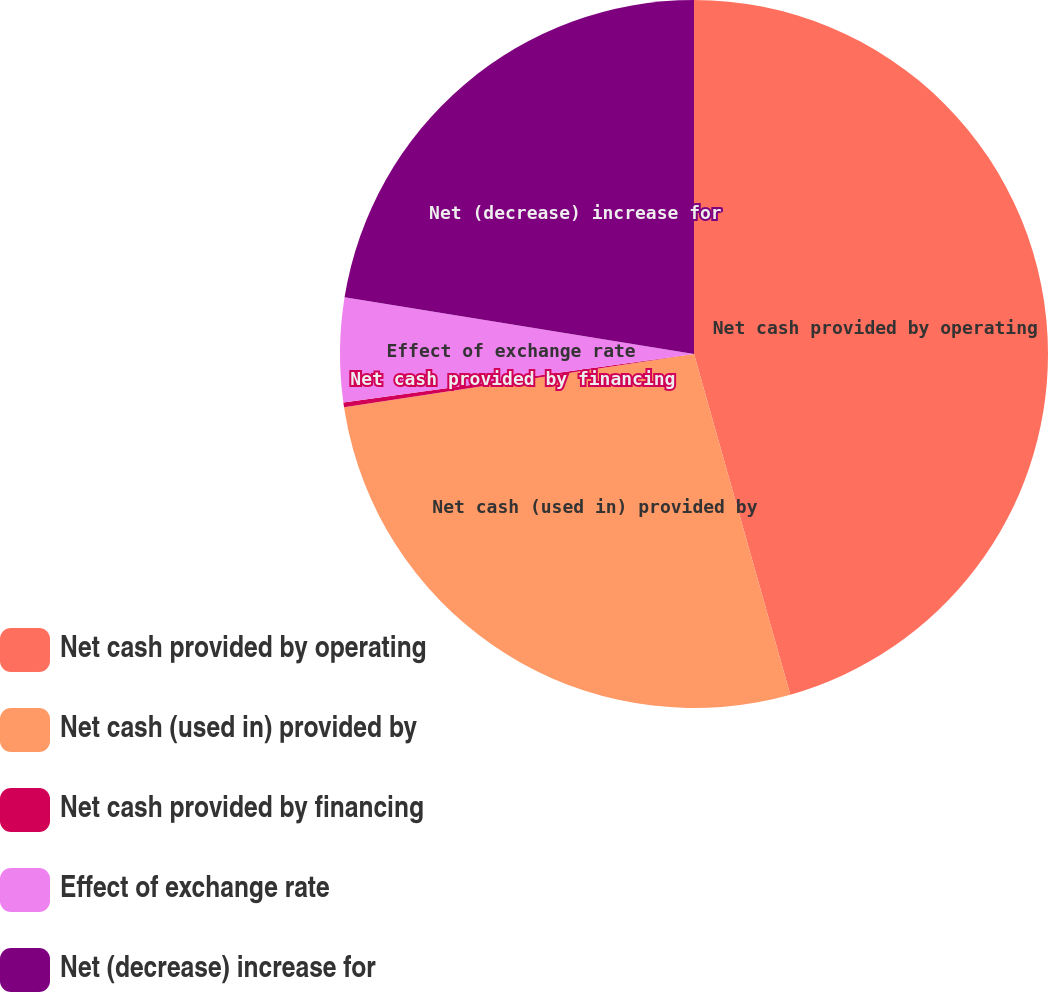Convert chart. <chart><loc_0><loc_0><loc_500><loc_500><pie_chart><fcel>Net cash provided by operating<fcel>Net cash (used in) provided by<fcel>Net cash provided by financing<fcel>Effect of exchange rate<fcel>Net (decrease) increase for<nl><fcel>45.61%<fcel>26.98%<fcel>0.21%<fcel>4.75%<fcel>22.44%<nl></chart> 